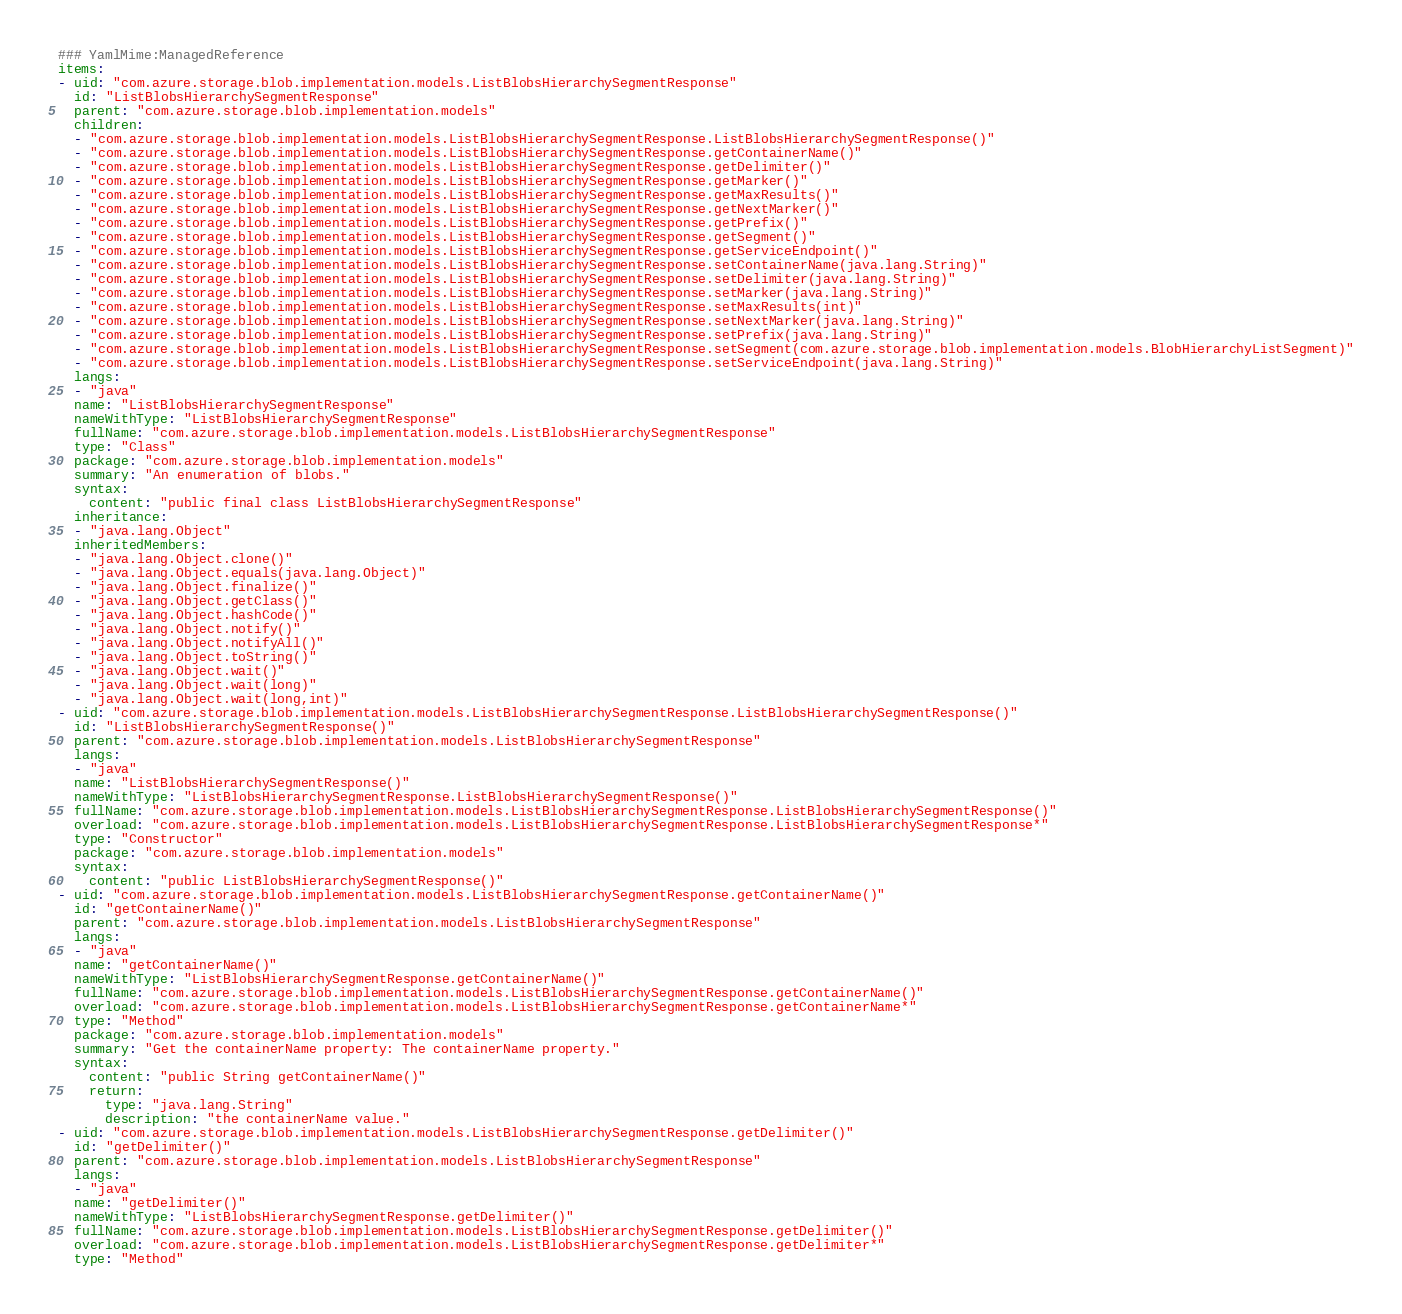<code> <loc_0><loc_0><loc_500><loc_500><_YAML_>### YamlMime:ManagedReference
items:
- uid: "com.azure.storage.blob.implementation.models.ListBlobsHierarchySegmentResponse"
  id: "ListBlobsHierarchySegmentResponse"
  parent: "com.azure.storage.blob.implementation.models"
  children:
  - "com.azure.storage.blob.implementation.models.ListBlobsHierarchySegmentResponse.ListBlobsHierarchySegmentResponse()"
  - "com.azure.storage.blob.implementation.models.ListBlobsHierarchySegmentResponse.getContainerName()"
  - "com.azure.storage.blob.implementation.models.ListBlobsHierarchySegmentResponse.getDelimiter()"
  - "com.azure.storage.blob.implementation.models.ListBlobsHierarchySegmentResponse.getMarker()"
  - "com.azure.storage.blob.implementation.models.ListBlobsHierarchySegmentResponse.getMaxResults()"
  - "com.azure.storage.blob.implementation.models.ListBlobsHierarchySegmentResponse.getNextMarker()"
  - "com.azure.storage.blob.implementation.models.ListBlobsHierarchySegmentResponse.getPrefix()"
  - "com.azure.storage.blob.implementation.models.ListBlobsHierarchySegmentResponse.getSegment()"
  - "com.azure.storage.blob.implementation.models.ListBlobsHierarchySegmentResponse.getServiceEndpoint()"
  - "com.azure.storage.blob.implementation.models.ListBlobsHierarchySegmentResponse.setContainerName(java.lang.String)"
  - "com.azure.storage.blob.implementation.models.ListBlobsHierarchySegmentResponse.setDelimiter(java.lang.String)"
  - "com.azure.storage.blob.implementation.models.ListBlobsHierarchySegmentResponse.setMarker(java.lang.String)"
  - "com.azure.storage.blob.implementation.models.ListBlobsHierarchySegmentResponse.setMaxResults(int)"
  - "com.azure.storage.blob.implementation.models.ListBlobsHierarchySegmentResponse.setNextMarker(java.lang.String)"
  - "com.azure.storage.blob.implementation.models.ListBlobsHierarchySegmentResponse.setPrefix(java.lang.String)"
  - "com.azure.storage.blob.implementation.models.ListBlobsHierarchySegmentResponse.setSegment(com.azure.storage.blob.implementation.models.BlobHierarchyListSegment)"
  - "com.azure.storage.blob.implementation.models.ListBlobsHierarchySegmentResponse.setServiceEndpoint(java.lang.String)"
  langs:
  - "java"
  name: "ListBlobsHierarchySegmentResponse"
  nameWithType: "ListBlobsHierarchySegmentResponse"
  fullName: "com.azure.storage.blob.implementation.models.ListBlobsHierarchySegmentResponse"
  type: "Class"
  package: "com.azure.storage.blob.implementation.models"
  summary: "An enumeration of blobs."
  syntax:
    content: "public final class ListBlobsHierarchySegmentResponse"
  inheritance:
  - "java.lang.Object"
  inheritedMembers:
  - "java.lang.Object.clone()"
  - "java.lang.Object.equals(java.lang.Object)"
  - "java.lang.Object.finalize()"
  - "java.lang.Object.getClass()"
  - "java.lang.Object.hashCode()"
  - "java.lang.Object.notify()"
  - "java.lang.Object.notifyAll()"
  - "java.lang.Object.toString()"
  - "java.lang.Object.wait()"
  - "java.lang.Object.wait(long)"
  - "java.lang.Object.wait(long,int)"
- uid: "com.azure.storage.blob.implementation.models.ListBlobsHierarchySegmentResponse.ListBlobsHierarchySegmentResponse()"
  id: "ListBlobsHierarchySegmentResponse()"
  parent: "com.azure.storage.blob.implementation.models.ListBlobsHierarchySegmentResponse"
  langs:
  - "java"
  name: "ListBlobsHierarchySegmentResponse()"
  nameWithType: "ListBlobsHierarchySegmentResponse.ListBlobsHierarchySegmentResponse()"
  fullName: "com.azure.storage.blob.implementation.models.ListBlobsHierarchySegmentResponse.ListBlobsHierarchySegmentResponse()"
  overload: "com.azure.storage.blob.implementation.models.ListBlobsHierarchySegmentResponse.ListBlobsHierarchySegmentResponse*"
  type: "Constructor"
  package: "com.azure.storage.blob.implementation.models"
  syntax:
    content: "public ListBlobsHierarchySegmentResponse()"
- uid: "com.azure.storage.blob.implementation.models.ListBlobsHierarchySegmentResponse.getContainerName()"
  id: "getContainerName()"
  parent: "com.azure.storage.blob.implementation.models.ListBlobsHierarchySegmentResponse"
  langs:
  - "java"
  name: "getContainerName()"
  nameWithType: "ListBlobsHierarchySegmentResponse.getContainerName()"
  fullName: "com.azure.storage.blob.implementation.models.ListBlobsHierarchySegmentResponse.getContainerName()"
  overload: "com.azure.storage.blob.implementation.models.ListBlobsHierarchySegmentResponse.getContainerName*"
  type: "Method"
  package: "com.azure.storage.blob.implementation.models"
  summary: "Get the containerName property: The containerName property."
  syntax:
    content: "public String getContainerName()"
    return:
      type: "java.lang.String"
      description: "the containerName value."
- uid: "com.azure.storage.blob.implementation.models.ListBlobsHierarchySegmentResponse.getDelimiter()"
  id: "getDelimiter()"
  parent: "com.azure.storage.blob.implementation.models.ListBlobsHierarchySegmentResponse"
  langs:
  - "java"
  name: "getDelimiter()"
  nameWithType: "ListBlobsHierarchySegmentResponse.getDelimiter()"
  fullName: "com.azure.storage.blob.implementation.models.ListBlobsHierarchySegmentResponse.getDelimiter()"
  overload: "com.azure.storage.blob.implementation.models.ListBlobsHierarchySegmentResponse.getDelimiter*"
  type: "Method"</code> 